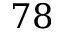Convert formula to latex. <formula><loc_0><loc_0><loc_500><loc_500>7 8</formula> 